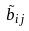<formula> <loc_0><loc_0><loc_500><loc_500>\tilde { b } _ { i j }</formula> 